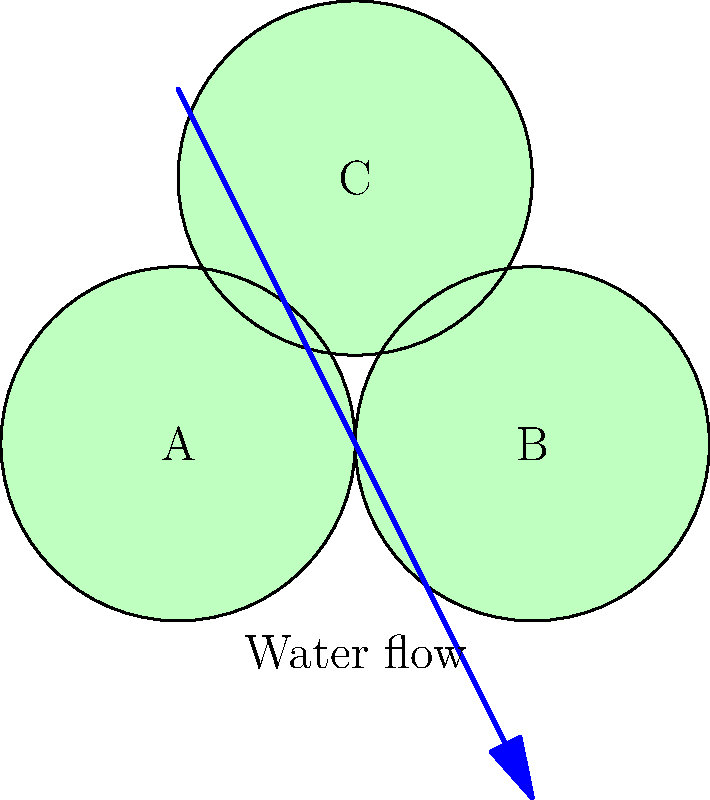In the wetland restoration project shown above, three circular wetland areas (A, B, and C) are proposed. Given that the water flows diagonally from top-left to bottom-right, which arrangement of habitat types would best optimize the ecological benefits while considering the water flow? Choose from:
1. Shallow marsh (A), Deep marsh (B), Forested wetland (C)
2. Forested wetland (A), Shallow marsh (B), Deep marsh (C)
3. Deep marsh (A), Forested wetland (B), Shallow marsh (C) To optimize the layout of the wetland restoration project, we need to consider the following factors:

1. Water flow: The diagram shows water flowing diagonally from top-left to bottom-right.

2. Habitat types:
   - Shallow marsh: Requires less water depth, suitable for early stages of water flow.
   - Deep marsh: Requires more water depth, ideal for later stages of water flow.
   - Forested wetland: Can act as a buffer and filter, best placed between other habitat types.

3. Ecological benefits: We want to maximize biodiversity and water quality improvement.

Step-by-step analysis:
1. Area A receives water first, so it should be a habitat that can handle initial water flow and act as an initial filter. A shallow marsh is ideal for this position.

2. Area C is at the highest elevation and receives water indirectly. This makes it suitable for a forested wetland, which can thrive with less direct water flow and act as a buffer.

3. Area B is at the end of the water flow path, making it ideal for a deep marsh. This allows for maximum water retention and habitat for species requiring deeper water.

This arrangement (Shallow marsh (A), Deep marsh (B), Forested wetland (C)) provides a natural progression of water depth and habitat types, optimizing water flow, filtration, and ecological diversity.
Answer: 1. Shallow marsh (A), Deep marsh (B), Forested wetland (C) 